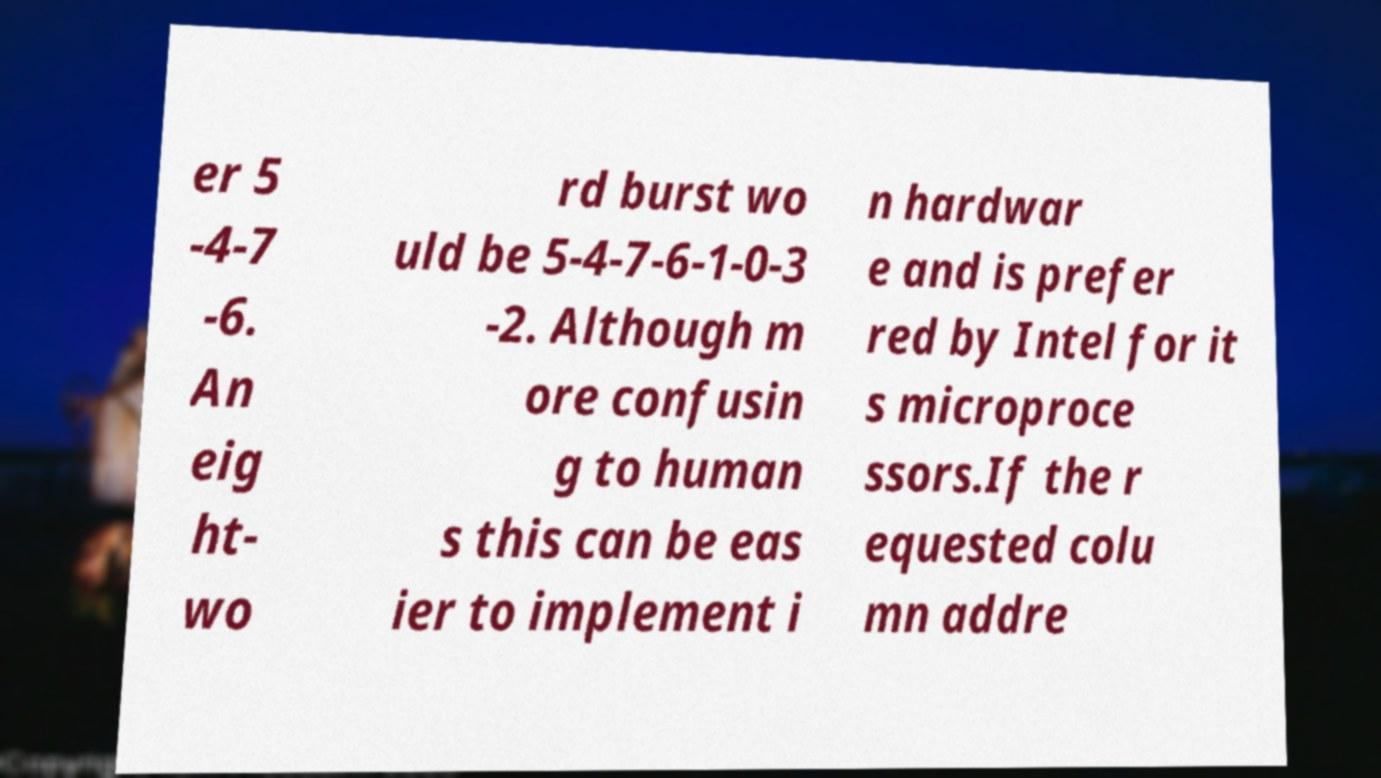For documentation purposes, I need the text within this image transcribed. Could you provide that? er 5 -4-7 -6. An eig ht- wo rd burst wo uld be 5-4-7-6-1-0-3 -2. Although m ore confusin g to human s this can be eas ier to implement i n hardwar e and is prefer red by Intel for it s microproce ssors.If the r equested colu mn addre 